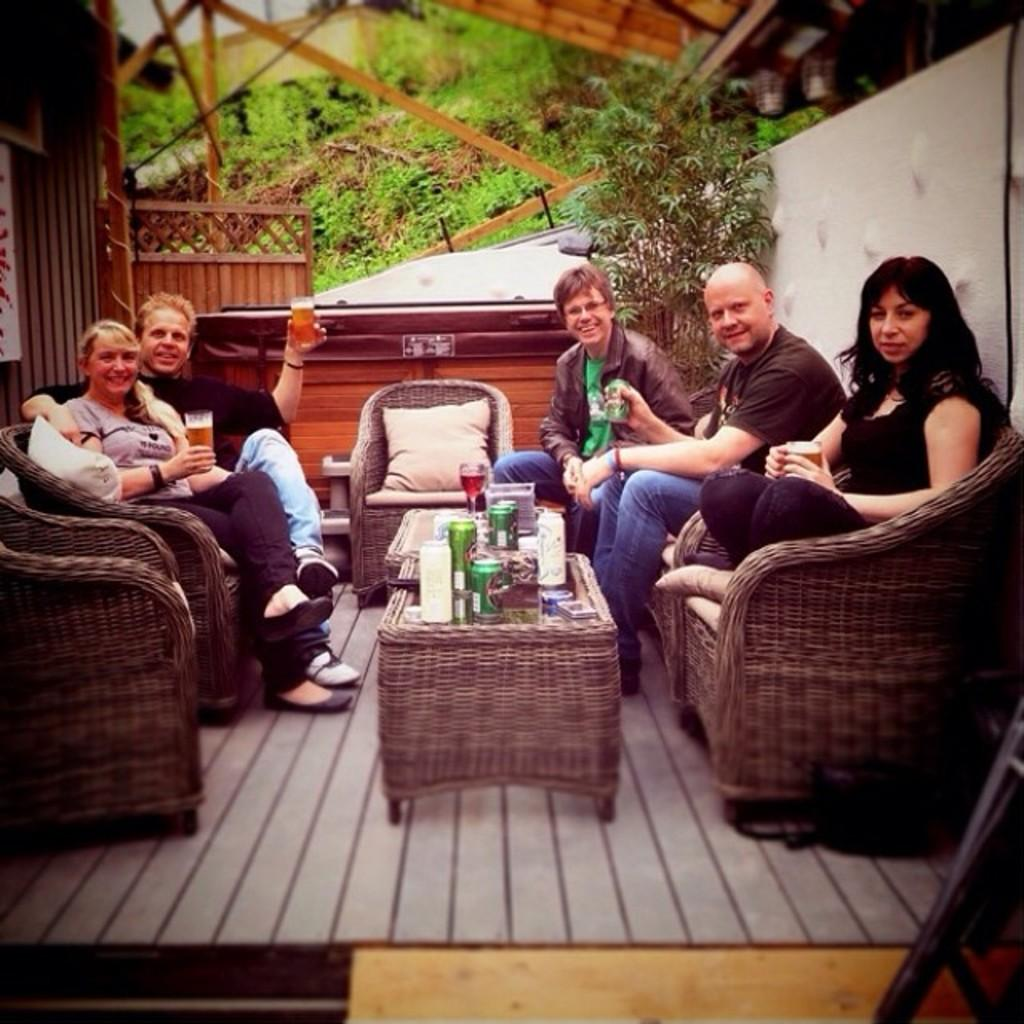How many people are sitting on the wooden chair in the image? There are five people sitting on the wooden chair in the image. Can you describe the facial expression of the man on the right side? The man on the right side is smiling. What type of furniture is present in the image? There is a wooden table in the image. What is on the wooden table? A glass of wine, a cock ring, and a mobile phone are present on the wooden table. How many ladybugs are crawling on the crate in the image? There is no crate or ladybugs present in the image. 